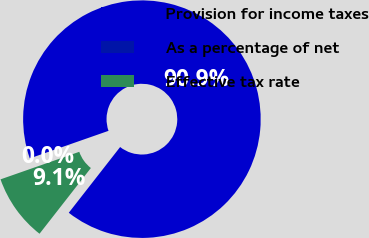<chart> <loc_0><loc_0><loc_500><loc_500><pie_chart><fcel>Provision for income taxes<fcel>As a percentage of net<fcel>Effective tax rate<nl><fcel>90.91%<fcel>0.0%<fcel>9.09%<nl></chart> 